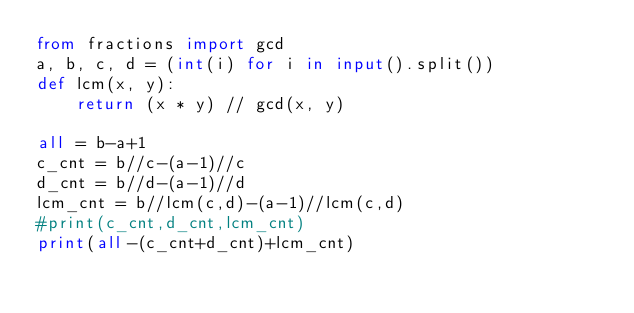Convert code to text. <code><loc_0><loc_0><loc_500><loc_500><_Python_>from fractions import gcd
a, b, c, d = (int(i) for i in input().split())
def lcm(x, y):
    return (x * y) // gcd(x, y)

all = b-a+1
c_cnt = b//c-(a-1)//c
d_cnt = b//d-(a-1)//d
lcm_cnt = b//lcm(c,d)-(a-1)//lcm(c,d)
#print(c_cnt,d_cnt,lcm_cnt)
print(all-(c_cnt+d_cnt)+lcm_cnt)
</code> 